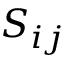Convert formula to latex. <formula><loc_0><loc_0><loc_500><loc_500>S _ { i j }</formula> 